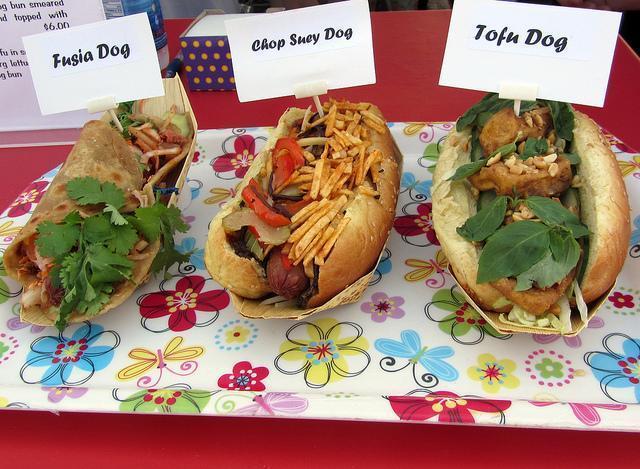How many sandwiches are there?
Give a very brief answer. 2. 